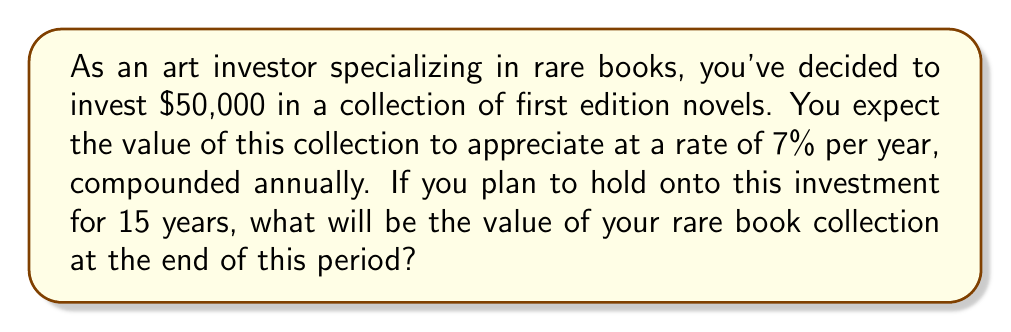Could you help me with this problem? To solve this problem, we'll use the compound interest formula:

$$A = P(1 + r)^n$$

Where:
$A$ = Final amount
$P$ = Principal (initial investment)
$r$ = Annual interest rate (as a decimal)
$n$ = Number of years

Given:
$P = $50,000$
$r = 7\% = 0.07$
$n = 15$ years

Let's substitute these values into the formula:

$$A = 50,000(1 + 0.07)^{15}$$

Now, let's calculate step by step:

1) First, calculate $(1 + 0.07)^{15}$:
   $$(1.07)^{15} \approx 2.7590$$

2) Multiply this by the principal:
   $$50,000 \times 2.7590 = 137,950$$

Therefore, after 15 years, the value of your rare book collection will be approximately $137,950.
Answer: $137,950 